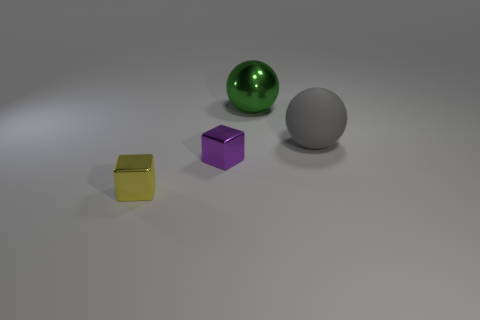What number of matte objects are blocks or tiny yellow blocks?
Offer a terse response. 0. What shape is the purple object?
Your response must be concise. Cube. Are there any other things that have the same material as the large gray sphere?
Offer a very short reply. No. Are the large green object and the purple block made of the same material?
Provide a short and direct response. Yes. Is there a green metal thing on the right side of the large object behind the sphere right of the large green shiny thing?
Provide a short and direct response. No. What number of other objects are the same shape as the gray rubber thing?
Your answer should be compact. 1. What is the shape of the metal object that is both on the right side of the tiny yellow metal thing and in front of the green sphere?
Keep it short and to the point. Cube. There is a object behind the big sphere that is in front of the big object behind the big rubber thing; what color is it?
Your answer should be compact. Green. Are there more green shiny things in front of the big gray matte thing than large gray spheres behind the green metallic object?
Provide a short and direct response. No. How many other things are there of the same size as the green metallic thing?
Ensure brevity in your answer.  1. 